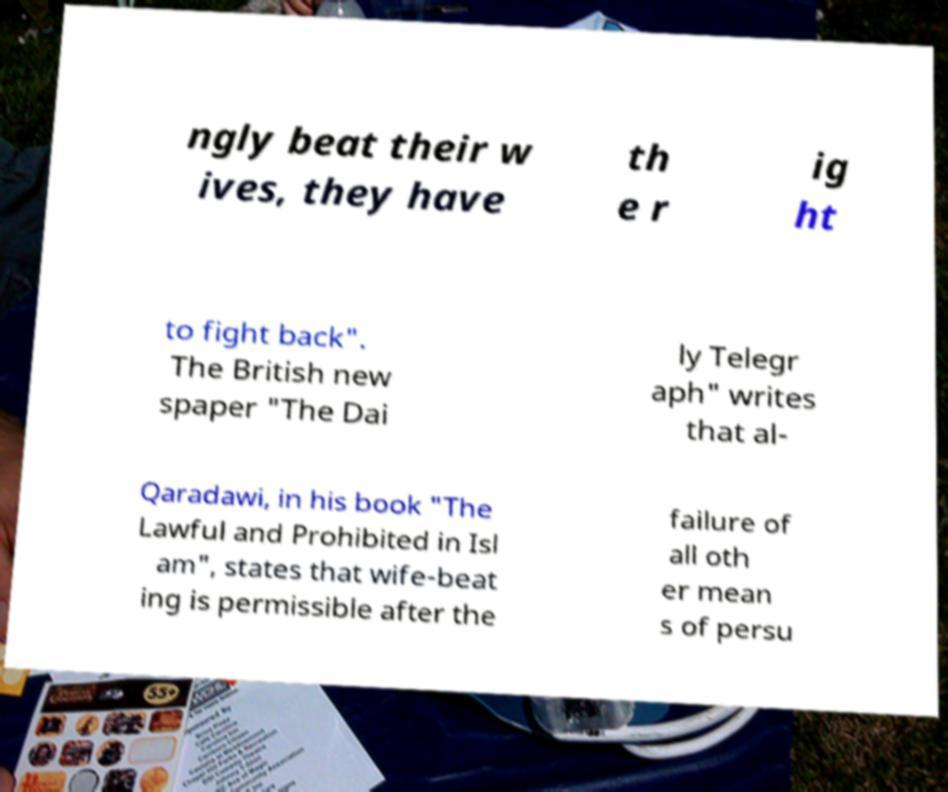What messages or text are displayed in this image? I need them in a readable, typed format. ngly beat their w ives, they have th e r ig ht to fight back". The British new spaper "The Dai ly Telegr aph" writes that al- Qaradawi, in his book "The Lawful and Prohibited in Isl am", states that wife-beat ing is permissible after the failure of all oth er mean s of persu 